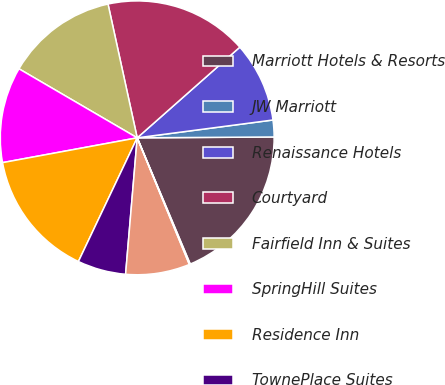Convert chart to OTSL. <chart><loc_0><loc_0><loc_500><loc_500><pie_chart><fcel>Marriott Hotels & Resorts<fcel>JW Marriott<fcel>Renaissance Hotels<fcel>Courtyard<fcel>Fairfield Inn & Suites<fcel>SpringHill Suites<fcel>Residence Inn<fcel>TownePlace Suites<fcel>The Ritz-Carlton<fcel>The Ritz-Carlton-Residential<nl><fcel>18.77%<fcel>1.98%<fcel>9.44%<fcel>16.9%<fcel>13.17%<fcel>11.31%<fcel>15.04%<fcel>5.71%<fcel>7.57%<fcel>0.11%<nl></chart> 